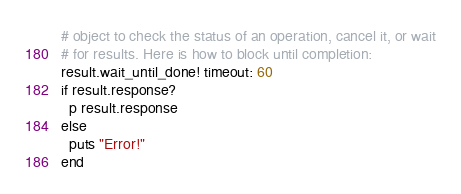Convert code to text. <code><loc_0><loc_0><loc_500><loc_500><_Ruby_># object to check the status of an operation, cancel it, or wait
# for results. Here is how to block until completion:
result.wait_until_done! timeout: 60
if result.response?
  p result.response
else
  puts "Error!"
end</code> 